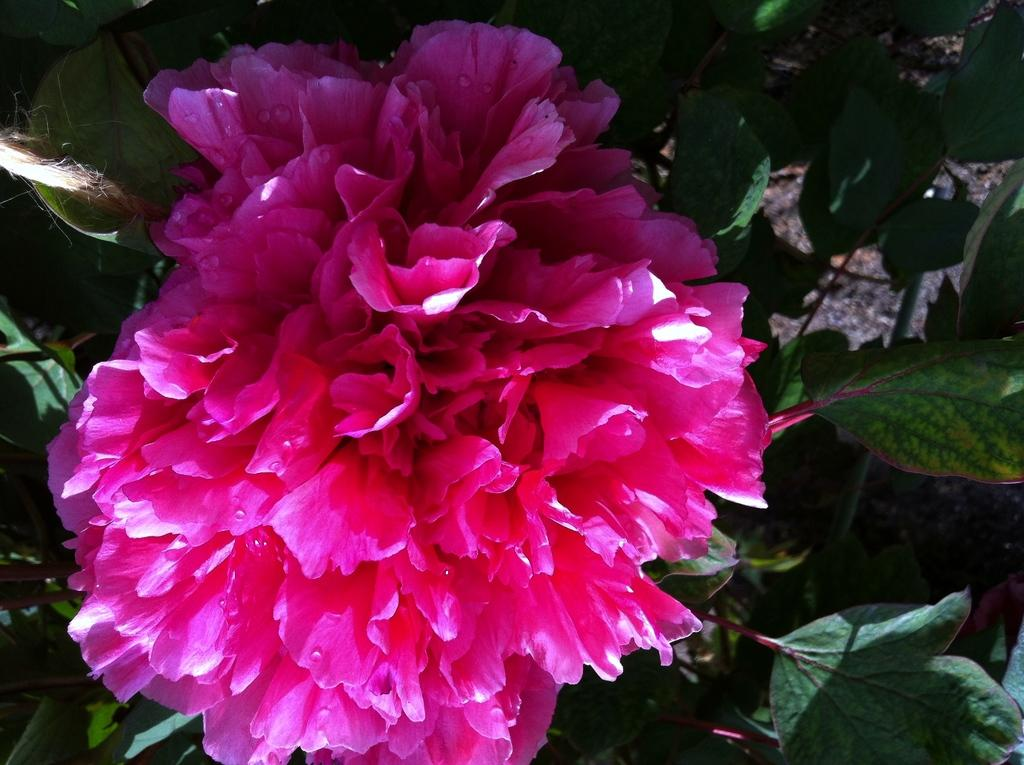What is the main subject of the image? There is a flower in the image. Is the flower part of a larger plant? Yes, the flower is attached to a plant. What else can be seen in the image besides the flower? There are leaves visible in the image. Can you describe the distribution of the mountain range in the image? There is no mountain range present in the image; it features a flower attached to a plant with leaves. 